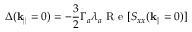Convert formula to latex. <formula><loc_0><loc_0><loc_500><loc_500>\Delta ( k _ { | | } = 0 ) = - \frac { 3 } { 2 } \Gamma _ { a } \lambda _ { a } R e [ S _ { x x } ( k _ { | | } = 0 ) ]</formula> 